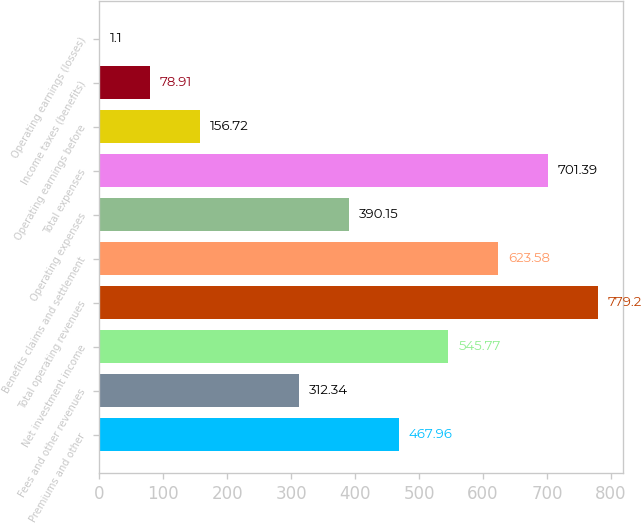<chart> <loc_0><loc_0><loc_500><loc_500><bar_chart><fcel>Premiums and other<fcel>Fees and other revenues<fcel>Net investment income<fcel>Total operating revenues<fcel>Benefits claims and settlement<fcel>Operating expenses<fcel>Total expenses<fcel>Operating earnings before<fcel>Income taxes (benefits)<fcel>Operating earnings (losses)<nl><fcel>467.96<fcel>312.34<fcel>545.77<fcel>779.2<fcel>623.58<fcel>390.15<fcel>701.39<fcel>156.72<fcel>78.91<fcel>1.1<nl></chart> 